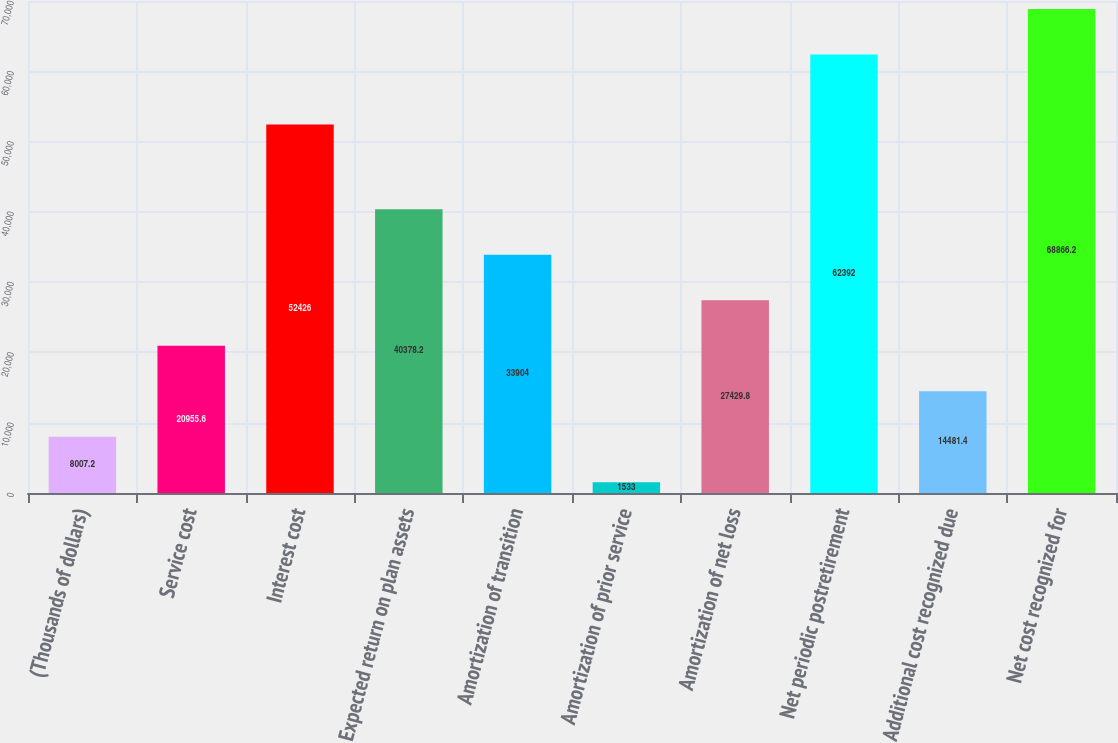Convert chart. <chart><loc_0><loc_0><loc_500><loc_500><bar_chart><fcel>(Thousands of dollars)<fcel>Service cost<fcel>Interest cost<fcel>Expected return on plan assets<fcel>Amortization of transition<fcel>Amortization of prior service<fcel>Amortization of net loss<fcel>Net periodic postretirement<fcel>Additional cost recognized due<fcel>Net cost recognized for<nl><fcel>8007.2<fcel>20955.6<fcel>52426<fcel>40378.2<fcel>33904<fcel>1533<fcel>27429.8<fcel>62392<fcel>14481.4<fcel>68866.2<nl></chart> 